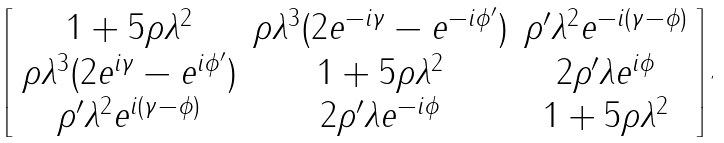Convert formula to latex. <formula><loc_0><loc_0><loc_500><loc_500>\left [ \begin{array} { c c c } 1 + 5 \rho \lambda ^ { 2 } & \rho \lambda ^ { 3 } ( 2 e ^ { - i \gamma } - e ^ { - i \phi ^ { \prime } } ) & \rho ^ { \prime } \lambda ^ { 2 } e ^ { - i ( \gamma - \phi ) } \\ \rho \lambda ^ { 3 } ( 2 e ^ { i \gamma } - e ^ { i \phi ^ { \prime } } ) & 1 + 5 \rho \lambda ^ { 2 } & 2 \rho ^ { \prime } \lambda e ^ { i \phi } \\ \rho ^ { \prime } \lambda ^ { 2 } e ^ { i ( \gamma - \phi ) } & 2 \rho ^ { \prime } \lambda e ^ { - i \phi } & 1 + 5 \rho \lambda ^ { 2 } \end{array} \right ] ,</formula> 